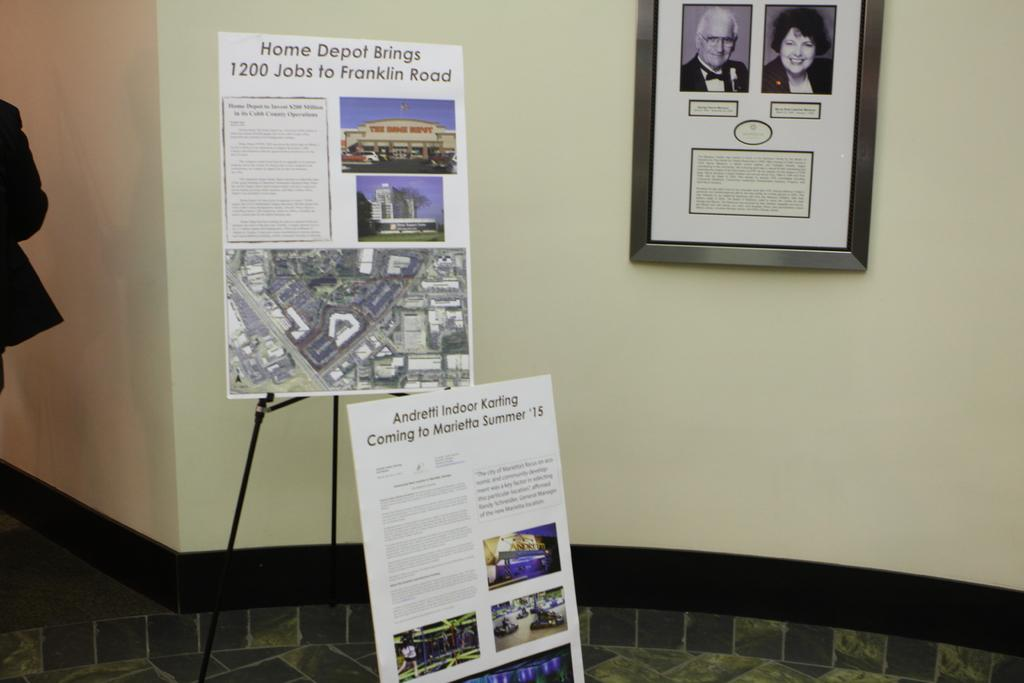What objects can be seen in the image? There are two boards and a stand in the image. How are the boards positioned in the image? The boards are attached to a frame that is attached to the wall. What is the color of the wall in the image? The wall is in white and black color. Can you describe the person visible in the background of the image? There is a person visible in the background of the image, but no specific details about the person are provided. What type of corn is being eaten by the person in the image? There is no corn present in the image, and no person is shown eating anything. 